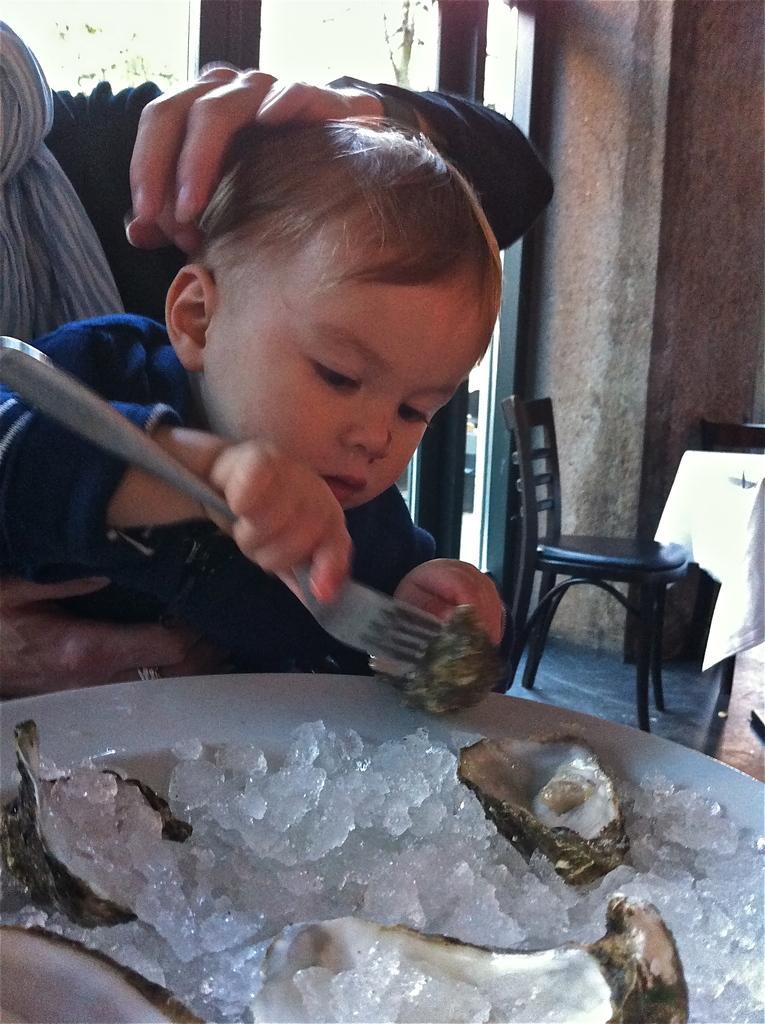In one or two sentences, can you explain what this image depicts? In this image there is a plate, in that plate there is food item, behind the plate there is a woman sitting on chair and holding a baby and that baby holding a fork in his hand, in the background there is a table and chair and a wall. 